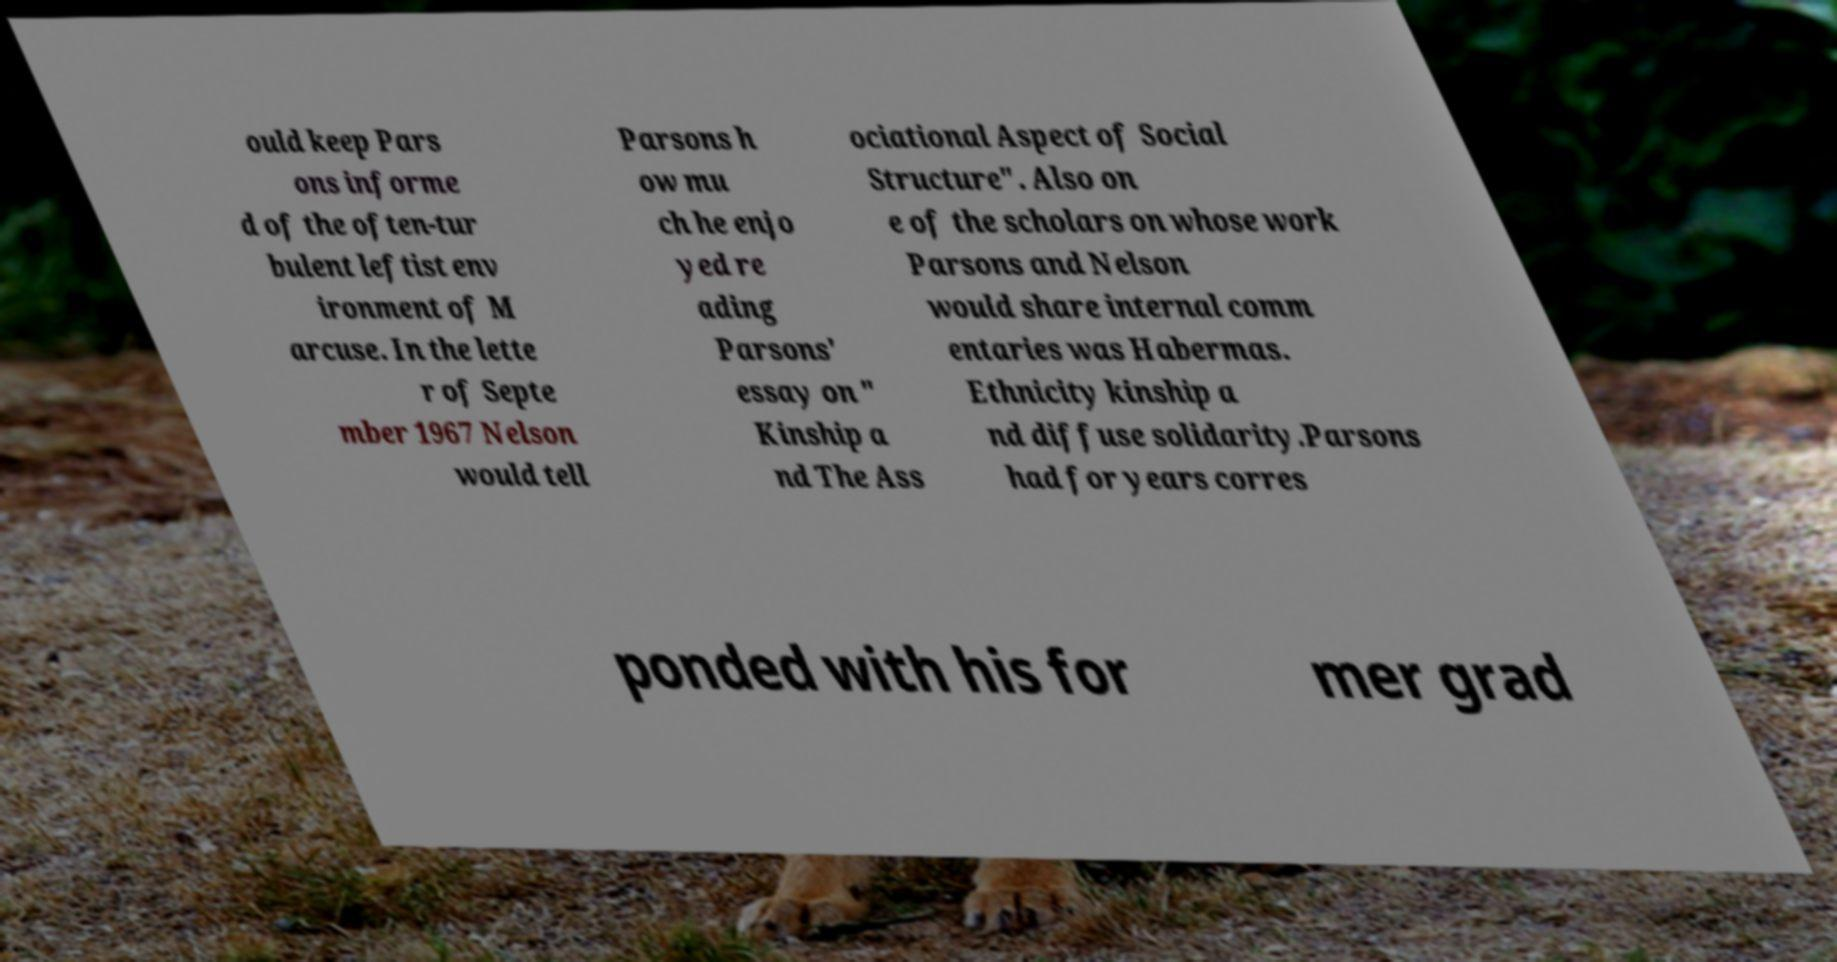For documentation purposes, I need the text within this image transcribed. Could you provide that? ould keep Pars ons informe d of the often-tur bulent leftist env ironment of M arcuse. In the lette r of Septe mber 1967 Nelson would tell Parsons h ow mu ch he enjo yed re ading Parsons' essay on " Kinship a nd The Ass ociational Aspect of Social Structure". Also on e of the scholars on whose work Parsons and Nelson would share internal comm entaries was Habermas. Ethnicity kinship a nd diffuse solidarity.Parsons had for years corres ponded with his for mer grad 